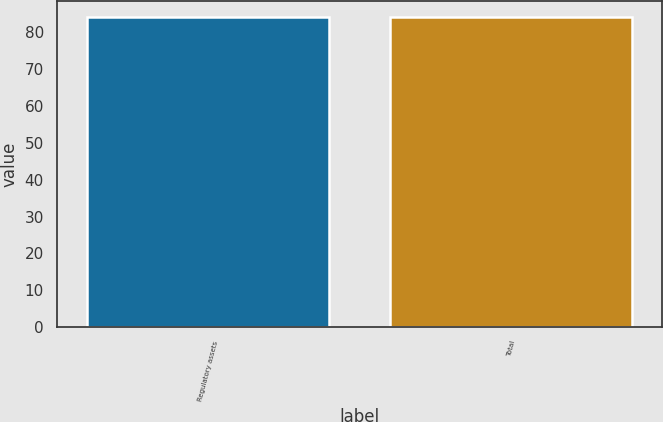Convert chart to OTSL. <chart><loc_0><loc_0><loc_500><loc_500><bar_chart><fcel>Regulatory assets<fcel>Total<nl><fcel>84<fcel>84.1<nl></chart> 